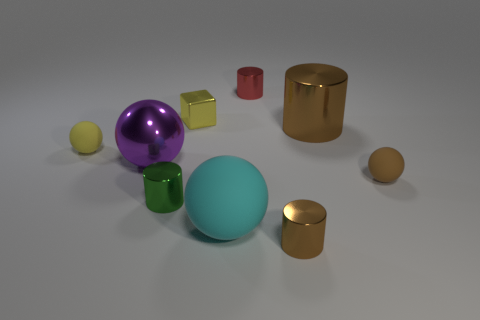What number of small green cylinders are there?
Your response must be concise. 1. There is a ball that is on the right side of the cyan object; what is its color?
Your answer should be compact. Brown. The tiny cylinder that is in front of the large ball right of the purple thing is what color?
Offer a terse response. Brown. There is a metallic cube that is the same size as the green metal cylinder; what color is it?
Keep it short and to the point. Yellow. How many tiny objects are in front of the big cylinder and behind the purple metal object?
Offer a terse response. 1. There is a small metallic object that is the same color as the big metal cylinder; what shape is it?
Ensure brevity in your answer.  Cylinder. There is a small thing that is behind the small yellow rubber ball and in front of the tiny red cylinder; what material is it made of?
Your response must be concise. Metal. Are there fewer small green shiny things that are to the right of the small brown ball than small red cylinders that are behind the tiny brown cylinder?
Your answer should be very brief. Yes. There is a cube that is made of the same material as the large brown cylinder; what is its size?
Offer a terse response. Small. Is there anything else that has the same color as the big metal sphere?
Your response must be concise. No. 